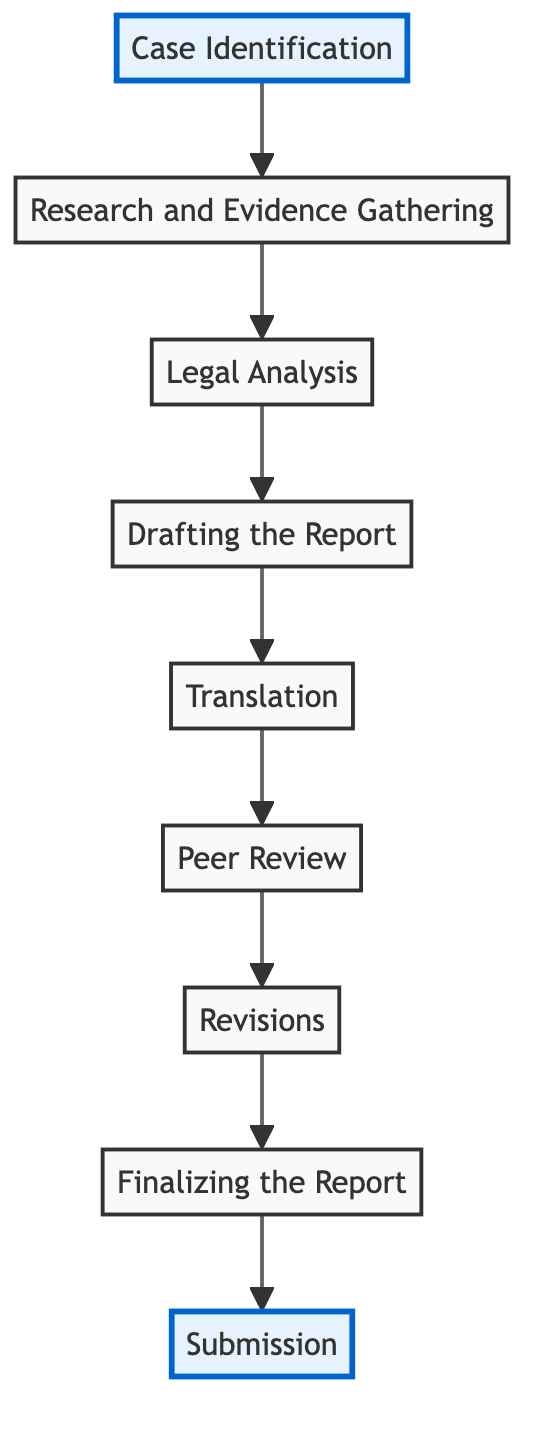What is the first step in preparing a human rights report? The first step is "Case Identification," where the issue to be reported is selected and identified.
Answer: Case Identification How many steps are involved in the entire process? By counting the boxes in the diagram, there are nine distinct steps in the process of preparing a human rights report.
Answer: 9 Which step comes after "Drafting the Report"? The step that follows "Drafting the Report" is "Translation," which ensures the report is accurately translated into necessary languages.
Answer: Translation What connects "Research and Evidence Gathering" and "Legal Analysis"? There is a directed edge connecting "Research and Evidence Gathering" to "Legal Analysis", indicating that the former is a prerequisite for the latter.
Answer: A directed edge What is the final step before submission in the process? The final step before submission is "Finalizing the Report," which involves proofreading and formatting the final version of the report.
Answer: Finalizing the Report What is the relationship between "Peer Review" and "Revisions"? "Peer Review" is followed by "Revisions", indicating that feedback from the review is incorporated into the report during the revision process.
Answer: Peer Review is followed by Revisions In which step is the report translated? The report is translated in the step labeled "Translation," which comes immediately after the drafting of the report.
Answer: Translation Which steps are highlighted in the diagram? The highlighted steps are "Case Identification" and "Submission," indicating their importance in the overall process.
Answer: Case Identification and Submission 